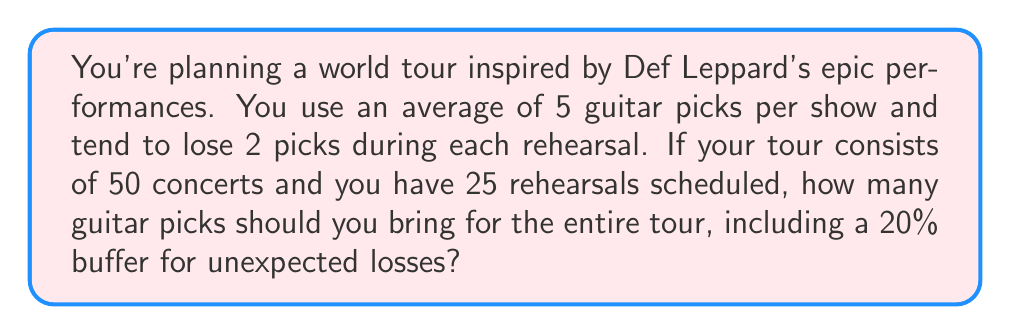Help me with this question. Let's break this down step-by-step:

1. Calculate picks needed for concerts:
   $$ \text{Concert picks} = 50 \text{ concerts} \times 5 \text{ picks/concert} = 250 \text{ picks} $$

2. Calculate picks needed for rehearsals:
   $$ \text{Rehearsal picks} = 25 \text{ rehearsals} \times 2 \text{ picks/rehearsal} = 50 \text{ picks} $$

3. Sum up the total picks needed:
   $$ \text{Total picks} = \text{Concert picks} + \text{Rehearsal picks} = 250 + 50 = 300 \text{ picks} $$

4. Add a 20% buffer for unexpected losses:
   $$ \text{Buffer} = 20\% \text{ of } 300 = 0.2 \times 300 = 60 \text{ picks} $$

5. Calculate the final number of picks needed:
   $$ \text{Final total} = \text{Total picks} + \text{Buffer} = 300 + 60 = 360 \text{ picks} $$
Answer: $360$ guitar picks 